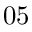<formula> <loc_0><loc_0><loc_500><loc_500>0 5</formula> 